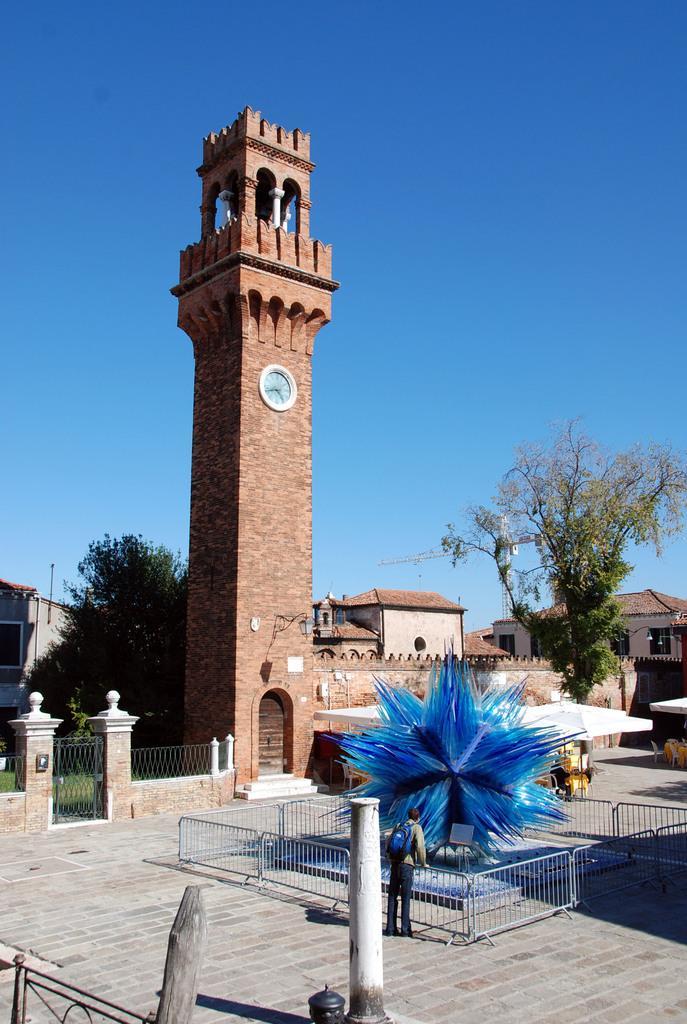Describe this image in one or two sentences. In this image there are some buildings and in the center there is one clock tower, gates, railing and some trees. And at the bottom there is one person standing, and there is some tree railing and at the bottom there is walkway and some wooden poles. And at the top there is sky, and on the right side there are some objects. 